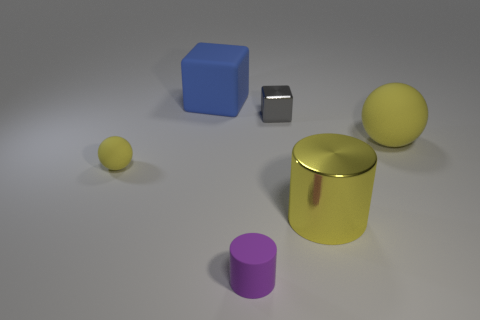Does the cylinder that is behind the purple matte cylinder have the same color as the big matte sphere? Yes, both the cylinder behind the purple matte cylinder and the large sphere in the image have a similar hue of yellow, creating a harmonious color scheme in the composition. 